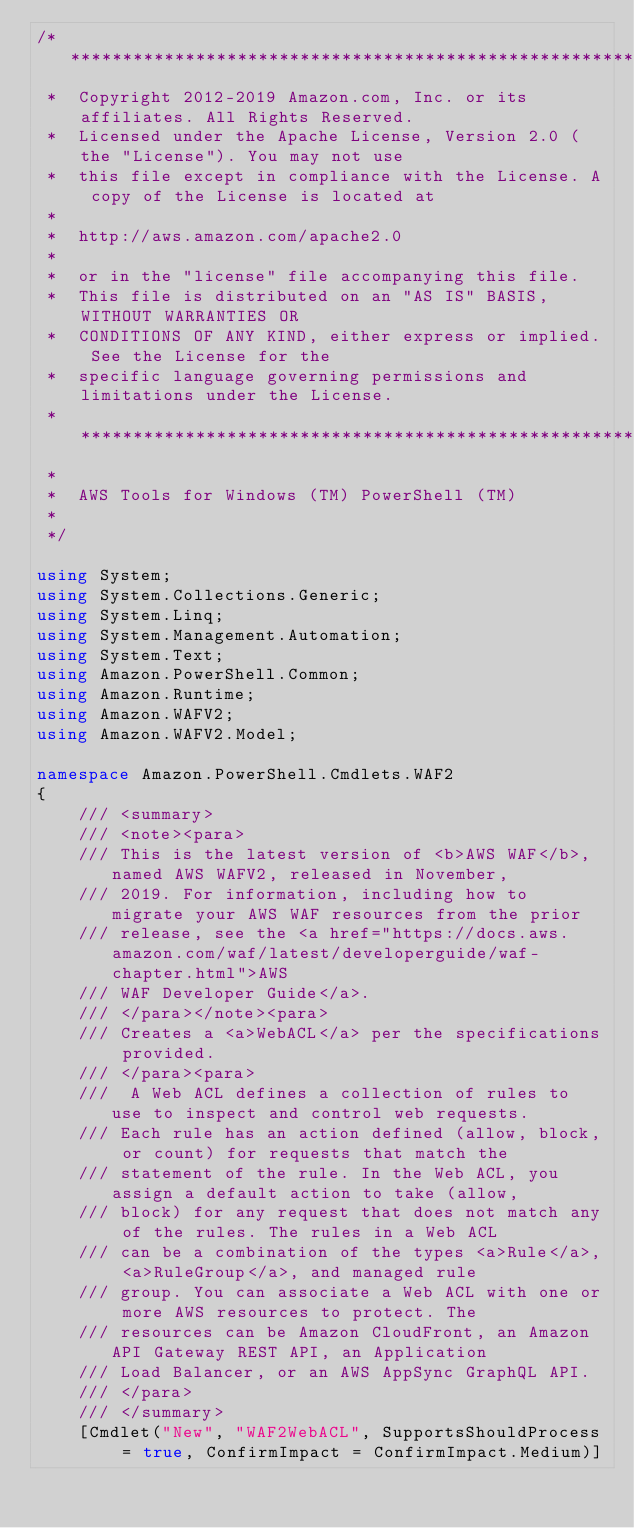Convert code to text. <code><loc_0><loc_0><loc_500><loc_500><_C#_>/*******************************************************************************
 *  Copyright 2012-2019 Amazon.com, Inc. or its affiliates. All Rights Reserved.
 *  Licensed under the Apache License, Version 2.0 (the "License"). You may not use
 *  this file except in compliance with the License. A copy of the License is located at
 *
 *  http://aws.amazon.com/apache2.0
 *
 *  or in the "license" file accompanying this file.
 *  This file is distributed on an "AS IS" BASIS, WITHOUT WARRANTIES OR
 *  CONDITIONS OF ANY KIND, either express or implied. See the License for the
 *  specific language governing permissions and limitations under the License.
 * *****************************************************************************
 *
 *  AWS Tools for Windows (TM) PowerShell (TM)
 *
 */

using System;
using System.Collections.Generic;
using System.Linq;
using System.Management.Automation;
using System.Text;
using Amazon.PowerShell.Common;
using Amazon.Runtime;
using Amazon.WAFV2;
using Amazon.WAFV2.Model;

namespace Amazon.PowerShell.Cmdlets.WAF2
{
    /// <summary>
    /// <note><para>
    /// This is the latest version of <b>AWS WAF</b>, named AWS WAFV2, released in November,
    /// 2019. For information, including how to migrate your AWS WAF resources from the prior
    /// release, see the <a href="https://docs.aws.amazon.com/waf/latest/developerguide/waf-chapter.html">AWS
    /// WAF Developer Guide</a>. 
    /// </para></note><para>
    /// Creates a <a>WebACL</a> per the specifications provided.
    /// </para><para>
    ///  A Web ACL defines a collection of rules to use to inspect and control web requests.
    /// Each rule has an action defined (allow, block, or count) for requests that match the
    /// statement of the rule. In the Web ACL, you assign a default action to take (allow,
    /// block) for any request that does not match any of the rules. The rules in a Web ACL
    /// can be a combination of the types <a>Rule</a>, <a>RuleGroup</a>, and managed rule
    /// group. You can associate a Web ACL with one or more AWS resources to protect. The
    /// resources can be Amazon CloudFront, an Amazon API Gateway REST API, an Application
    /// Load Balancer, or an AWS AppSync GraphQL API. 
    /// </para>
    /// </summary>
    [Cmdlet("New", "WAF2WebACL", SupportsShouldProcess = true, ConfirmImpact = ConfirmImpact.Medium)]</code> 